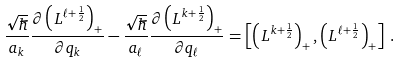Convert formula to latex. <formula><loc_0><loc_0><loc_500><loc_500>\frac { \sqrt { \hbar } } { a _ { k } } \frac { \partial \left ( L ^ { \ell + \frac { 1 } { 2 } } \right ) _ { + } } { \partial q _ { k } } - \frac { \sqrt { \hbar } } { a _ { \ell } } \frac { \partial \left ( L ^ { k + \frac { 1 } { 2 } } \right ) _ { + } } { \partial q _ { \ell } } = \left [ \left ( L ^ { k + \frac { 1 } { 2 } } \right ) _ { + } , \left ( L ^ { \ell + \frac { 1 } { 2 } } \right ) _ { + } \right ] \, .</formula> 